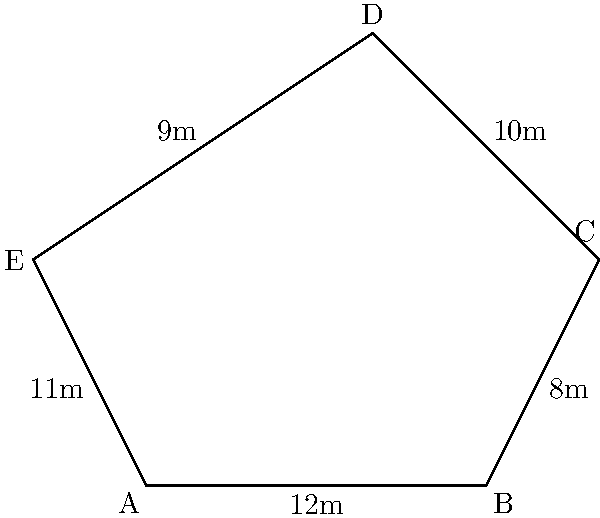As part of a new community policing initiative, the city plans to construct a pentagonal police station. The plot of land for the station is represented by the pentagon ABCDE in the diagram. Given that the sides of the pentagon measure AB = 12m, BC = 8m, CD = 10m, DE = 9m, and EA = 11m, calculate the perimeter of the police station plot. To calculate the perimeter of the pentagonal police station plot, we need to sum up the lengths of all sides. Let's break it down step by step:

1. Identify the given side lengths:
   - AB = 12m
   - BC = 8m
   - CD = 10m
   - DE = 9m
   - EA = 11m

2. The perimeter of a polygon is the sum of the lengths of all its sides. In this case, we have a pentagon, so we'll add all five side lengths.

3. Calculate the perimeter:
   Perimeter = AB + BC + CD + DE + EA
   Perimeter = 12m + 8m + 10m + 9m + 11m

4. Perform the addition:
   Perimeter = 50m

Therefore, the perimeter of the pentagonal police station plot is 50 meters.
Answer: 50m 